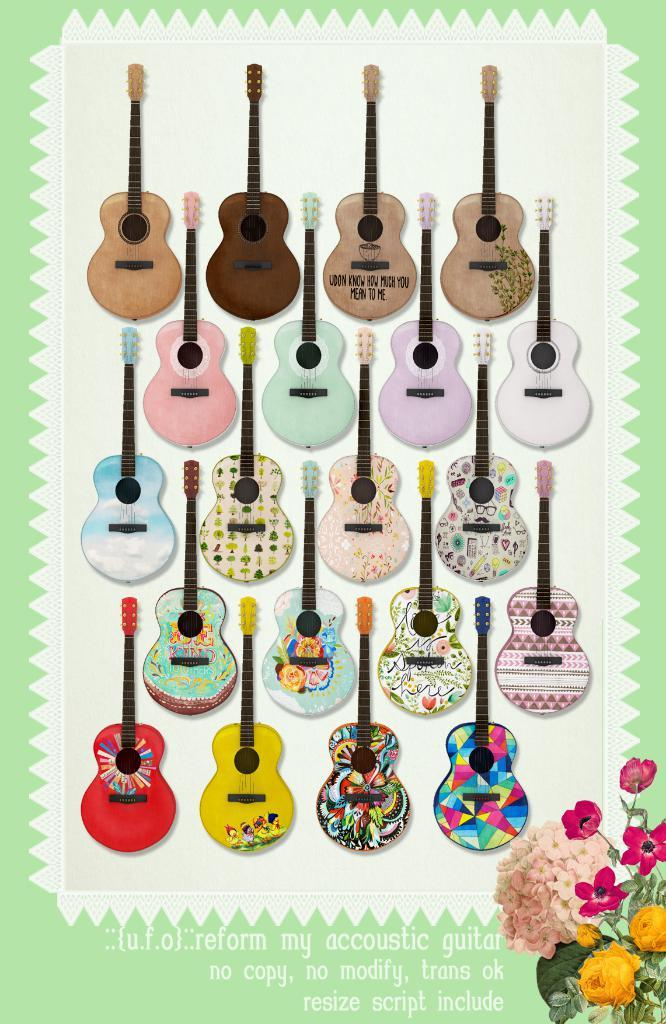What type of musical instruments are present in the image? There are many guitars in the image. How would you describe the appearance of the guitars? The guitars are colorful. What else can be seen in the image besides the guitars? There is text written in the image and flowers. What colors are the flowers in the image? The flowers are yellow and pink in color. Where are the flowers located in the image? The flowers are located in the right bottom of the image. How does the kitten stretch in the image? There is no kitten present in the image, so it cannot be determined how a kitten might stretch. 